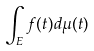<formula> <loc_0><loc_0><loc_500><loc_500>\int _ { E } f ( t ) d \mu ( t )</formula> 